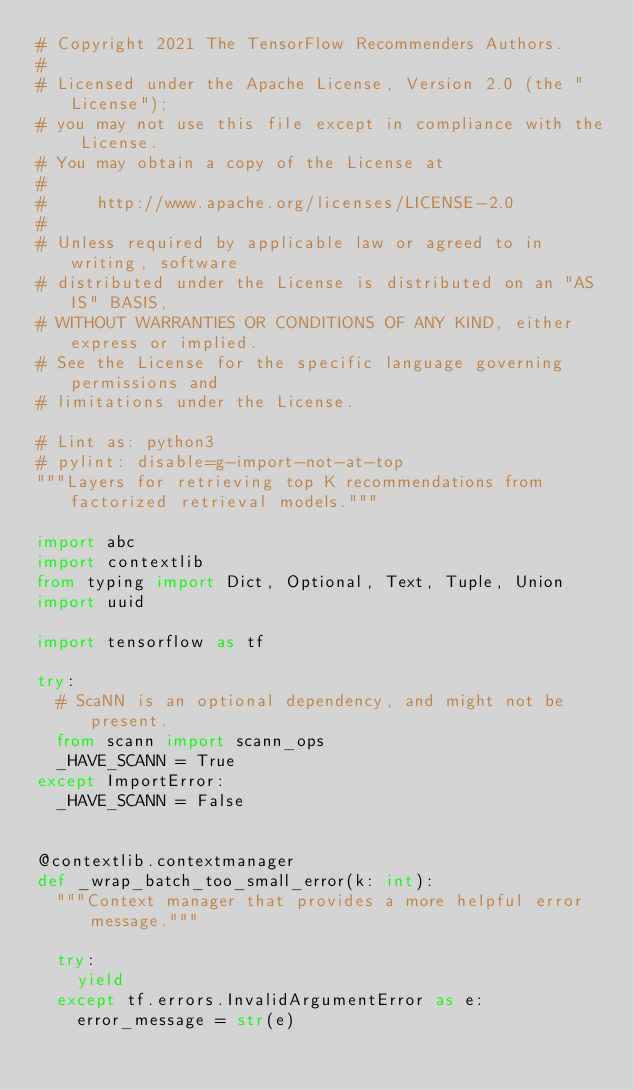Convert code to text. <code><loc_0><loc_0><loc_500><loc_500><_Python_># Copyright 2021 The TensorFlow Recommenders Authors.
#
# Licensed under the Apache License, Version 2.0 (the "License");
# you may not use this file except in compliance with the License.
# You may obtain a copy of the License at
#
#     http://www.apache.org/licenses/LICENSE-2.0
#
# Unless required by applicable law or agreed to in writing, software
# distributed under the License is distributed on an "AS IS" BASIS,
# WITHOUT WARRANTIES OR CONDITIONS OF ANY KIND, either express or implied.
# See the License for the specific language governing permissions and
# limitations under the License.

# Lint as: python3
# pylint: disable=g-import-not-at-top
"""Layers for retrieving top K recommendations from factorized retrieval models."""

import abc
import contextlib
from typing import Dict, Optional, Text, Tuple, Union
import uuid

import tensorflow as tf

try:
  # ScaNN is an optional dependency, and might not be present.
  from scann import scann_ops
  _HAVE_SCANN = True
except ImportError:
  _HAVE_SCANN = False


@contextlib.contextmanager
def _wrap_batch_too_small_error(k: int):
  """Context manager that provides a more helpful error message."""

  try:
    yield
  except tf.errors.InvalidArgumentError as e:
    error_message = str(e)</code> 